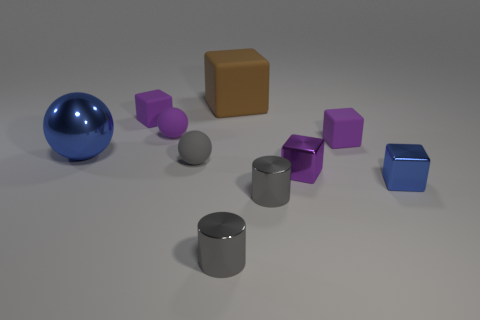Subtract all gray balls. How many balls are left? 2 Subtract all blue cubes. How many cubes are left? 4 Subtract all cylinders. How many objects are left? 8 Subtract 1 cylinders. How many cylinders are left? 1 Subtract all brown blocks. Subtract all purple spheres. How many blocks are left? 4 Subtract all purple cylinders. How many cyan spheres are left? 0 Subtract all big metal balls. Subtract all big brown blocks. How many objects are left? 8 Add 4 blocks. How many blocks are left? 9 Add 6 small metal cubes. How many small metal cubes exist? 8 Subtract 0 brown spheres. How many objects are left? 10 